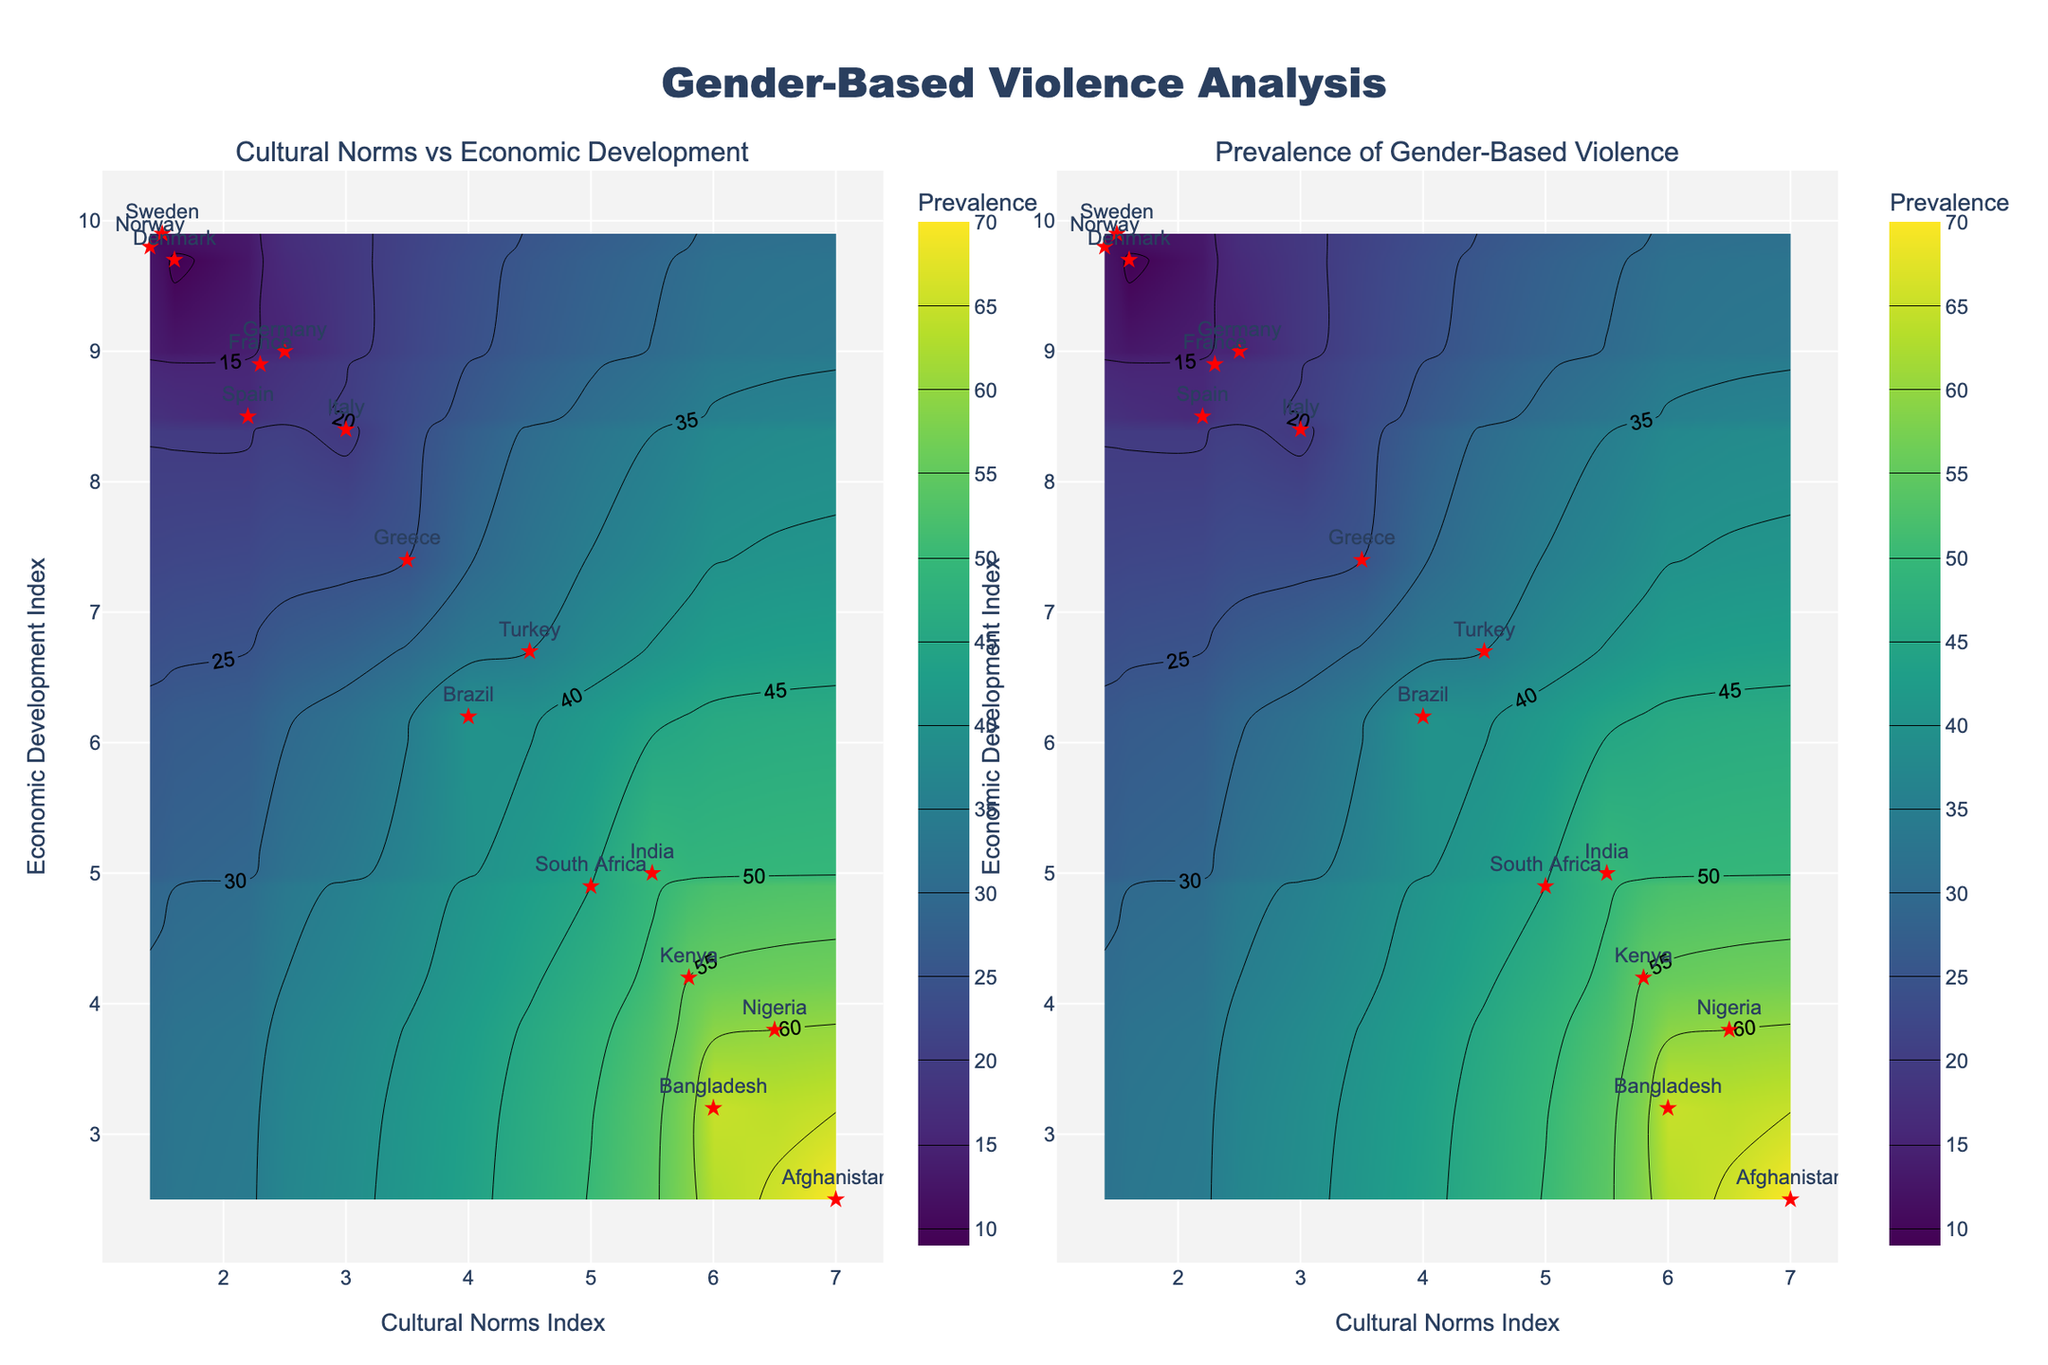What is the title of the entire figure? The title of the entire figure is located at the top center. The text is "Gender-Based Violence Analysis".
Answer: Gender-Based Violence Analysis What do the x-axis and y-axis represent in both contour plots? For both contour plots, the x-axis represents the "Cultural Norms Index" and the y-axis represents the "Economic Development Index". This information is found at the base of the x-axis and the side of the y-axis.
Answer: Cultural Norms Index and Economic Development Index Which country has the highest Prevalence of Gender-Based Violence? By examining the scatter plot points overlaid on the contour plots, we see "Afghanistan" positioned near the highest z-values on the plot (7.0 Cultural Norms Index and 2.5 Economic Development Index), which corresponds to the highest prevalence (70).
Answer: Afghanistan Is there a general trend between Economic Development Index and Prevalence of Gender-Based Violence? By observing the contour lines and color gradients, we see that as the Economic Development Index decreases, the prevalence of gender-based violence generally increases. This is evident from darker colors gathering towards the lower right quadrant of the plots.
Answer: As Economic Development decreases, Prevalence of Gender-Based Violence increases Which region shows both high Cultural Norms Index and high Economic Development Index with relatively low gender-based violence prevalence? In the top left of the plot, countries like Sweden, Norway, and Denmark, which have high Economic Development Index and relatively lower Cultural Norms Index values, show lower prevalence of gender-based violence.
Answer: Sweden, Norway, Denmark How does the Prevalence of Gender-Based Violence change as Cultural Norms Index increases from 1.5 to 7? By looking at the contour color changes from 1.5 to 7 on the x-axis, we observe that the color darkens, indicating a rise in the prevalence of gender-based violence as Cultural Norms Index rises. This can be seen with Afghanistan (7 index) having the highest violence prevalence.
Answer: Prevalence increases Which countries have the lowest prevalence of gender-based violence, and what are their Cultural Norms and Economic Development Indices? Examining the countries with scatter points at the lower contours (light color regions), we identify Sweden (Cultural Norms Index: 1.5, Economic Development Index: 9.9) as having one of the lowest prevalence rates of 10.
Answer: Sweden Based on the contour plots, where does Nigeria fall in terms of gender-based violence prevalence? Nigeria falls into higher Prevalence of Gender-Based Violence range (around 60). This can be identified by locating Nigeria's scatter point (Cultural Norms Index: 6.5, Economic Development Index: 3.8) and observing the corresponding contour color.
Answer: Around 60 What can you infer about the relationship between Cultural Norms Index and Economic Development Index with respect to gender-based violence? The two contour plots combined show that as the Cultural Norms Index increases and the Economic Development Index decreases, the prevalence of gender-based violence tends to increase significantly. This complex relationship indicates the cultural and economic influences on gender-based violence.
Answer: Increase in Cultural Norms Index (negative) and decrease in Economic Development Index lead to increase in prevalence Among the countries with higher cultural norms indices, which country has the lowest economic development index? Among the countries with higher Cultural Norms Indices (greater than 6), Afghanistan has the lowest Economic Development Index at 2.5, as shown on both contour plots.
Answer: Afghanistan 